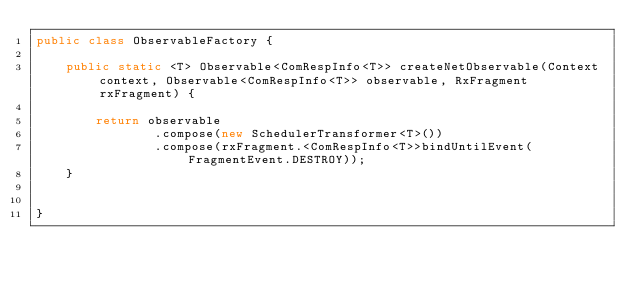<code> <loc_0><loc_0><loc_500><loc_500><_Java_>public class ObservableFactory {

    public static <T> Observable<ComRespInfo<T>> createNetObservable(Context context, Observable<ComRespInfo<T>> observable, RxFragment rxFragment) {

        return observable
                .compose(new SchedulerTransformer<T>())
                .compose(rxFragment.<ComRespInfo<T>>bindUntilEvent(FragmentEvent.DESTROY));
    }


}
</code> 